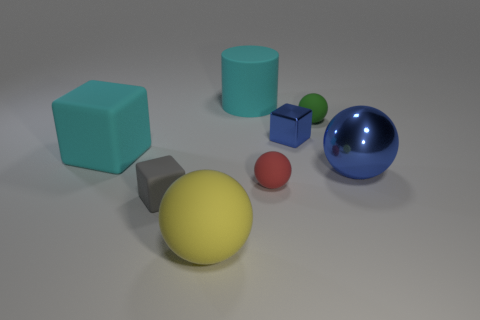Subtract 1 cubes. How many cubes are left? 2 Subtract all large metal spheres. How many spheres are left? 3 Subtract all yellow spheres. How many spheres are left? 3 Subtract all cyan balls. Subtract all green cylinders. How many balls are left? 4 Add 2 big blue matte spheres. How many objects exist? 10 Subtract all cylinders. How many objects are left? 7 Add 5 cyan rubber objects. How many cyan rubber objects are left? 7 Add 8 big cyan cylinders. How many big cyan cylinders exist? 9 Subtract 0 brown cylinders. How many objects are left? 8 Subtract all small yellow blocks. Subtract all metallic cubes. How many objects are left? 7 